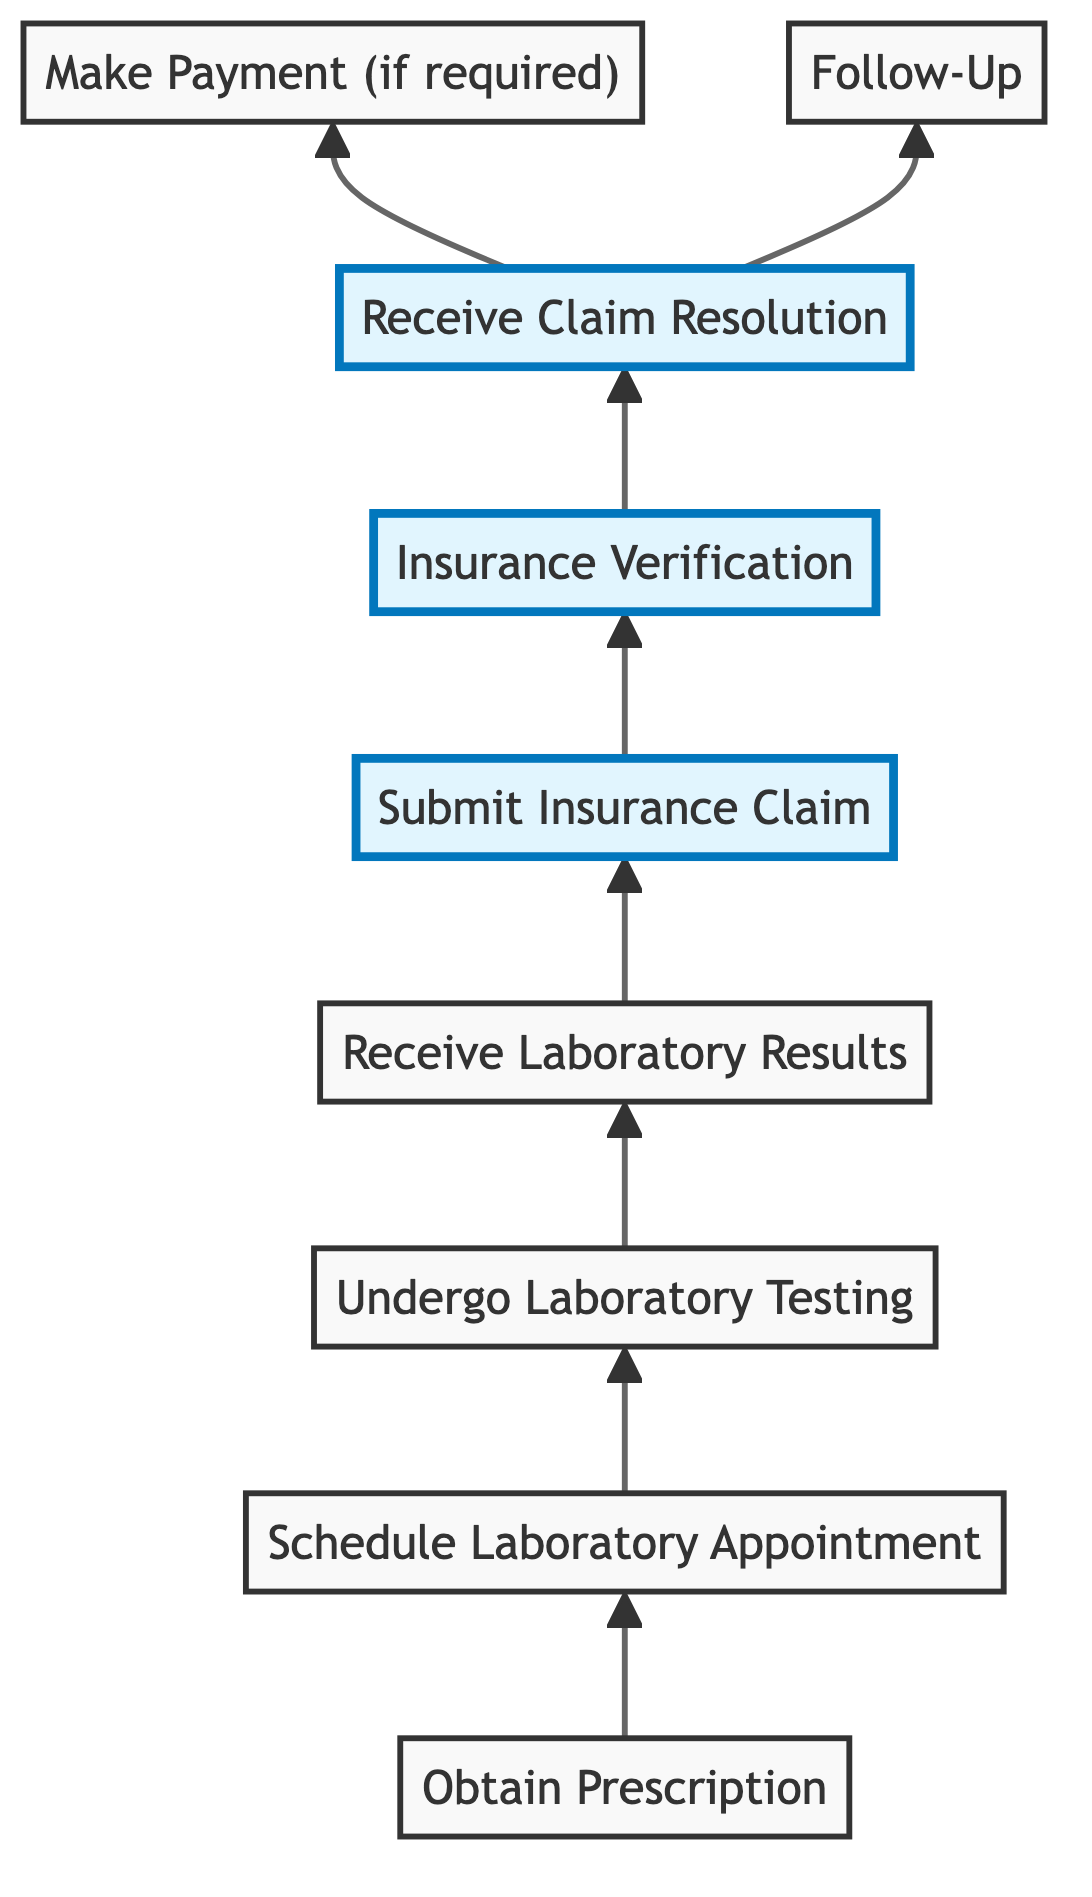What is the first step in the insurance claims process for ongoing laboratory services? The first step is "Obtain Prescription," which involves receiving a referral or prescription from a healthcare provider for necessary laboratory tests.
Answer: Obtain Prescription How many steps are there in the diagram? By counting the nodes in the diagram, there are a total of nine steps involved in the insurance claims process for ongoing laboratory services.
Answer: 9 What step follows "Submit Insurance Claim"? The next step after "Submit Insurance Claim" is "Insurance Verification," which ensures that the claim is verified and processed by the insurance company.
Answer: Insurance Verification Which step indicates that payment may be required? The step labeled "Make Payment (if required)" indicates that there may be a payment required depending on the claim resolution notification from the insurance provider.
Answer: Make Payment (if required) If a claim is denied, what should a person do next? If the claim is denied, the next action is to "Follow-Up," which involves gathering required information to resubmit or appeal the claim.
Answer: Follow-Up In the relationship hierarchy of steps, which step directly leads to both payment and follow-up actions? The "Receive Claim Resolution" step directly leads to both actions: if approved, it may lead to making a payment, and if denied, it leads to following up on the claim.
Answer: Receive Claim Resolution How does the process start? The process starts with obtaining a prescription from a healthcare provider for necessary laboratory tests, which is the first step in the flow chart.
Answer: Obtain Prescription What does the "Undergo Laboratory Testing" step entail? This step entails attending the laboratory appointment and completing the required tests, which is essential for obtaining results for the insurance claim process.
Answer: Undergo Laboratory Testing 